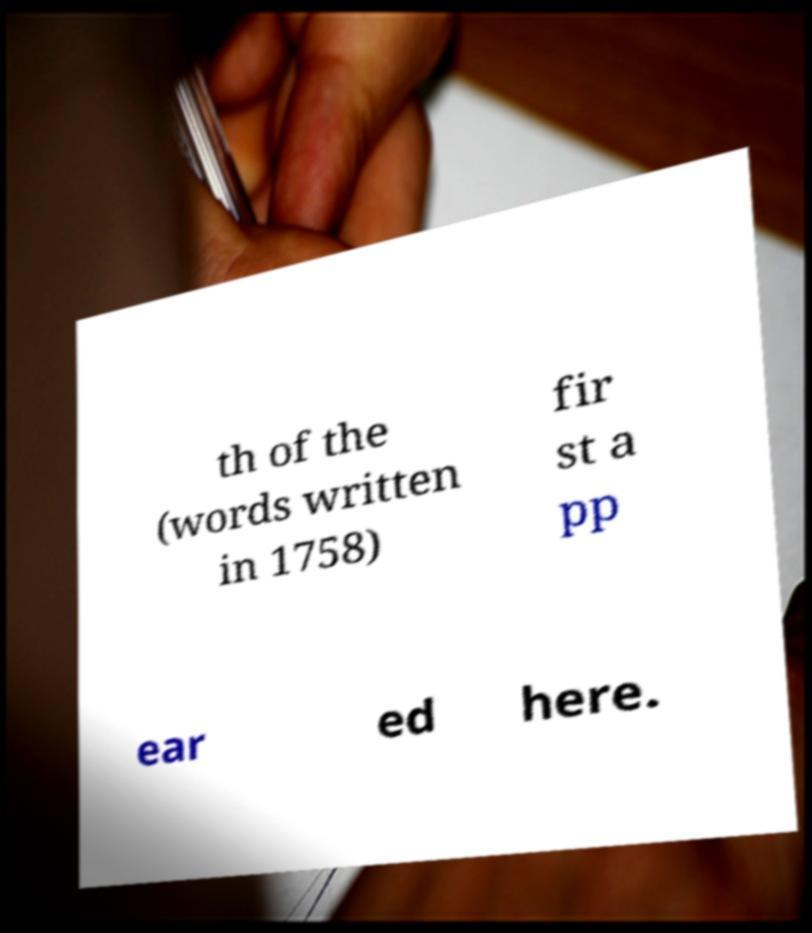I need the written content from this picture converted into text. Can you do that? th of the (words written in 1758) fir st a pp ear ed here. 